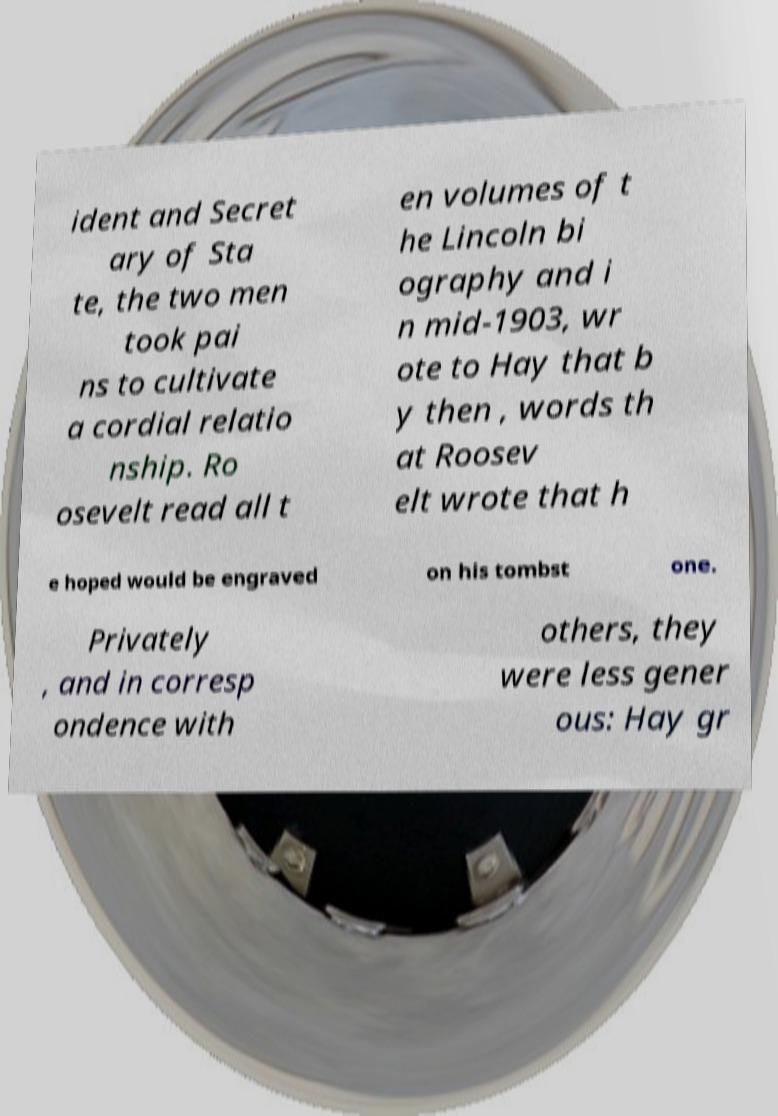Could you assist in decoding the text presented in this image and type it out clearly? ident and Secret ary of Sta te, the two men took pai ns to cultivate a cordial relatio nship. Ro osevelt read all t en volumes of t he Lincoln bi ography and i n mid-1903, wr ote to Hay that b y then , words th at Roosev elt wrote that h e hoped would be engraved on his tombst one. Privately , and in corresp ondence with others, they were less gener ous: Hay gr 